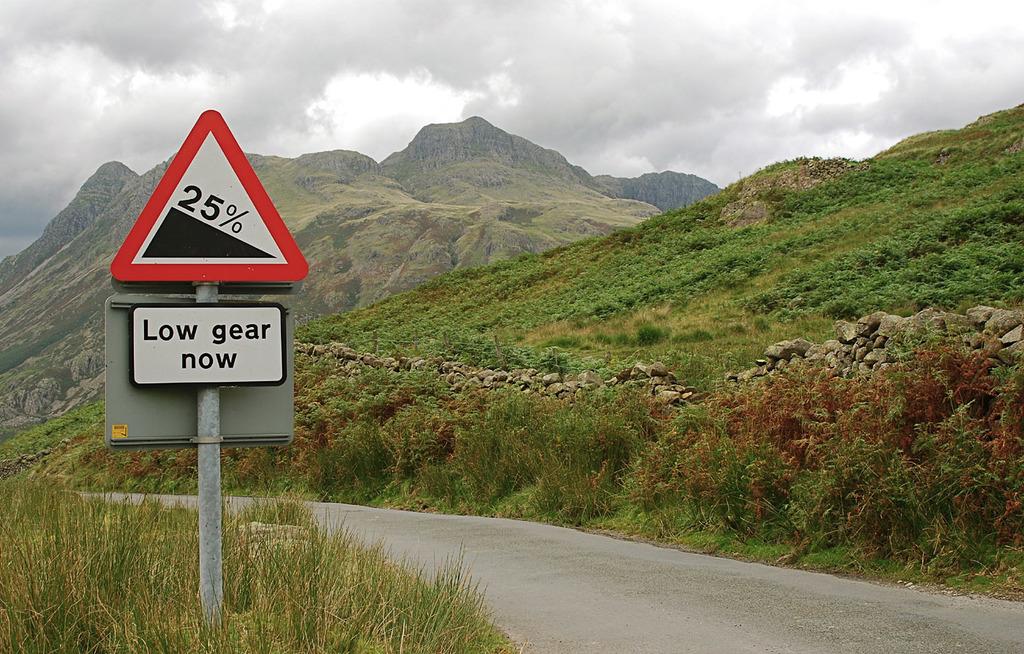What caution should you take?
Keep it short and to the point. Low gear now. Whats the sign warning?
Provide a short and direct response. Low gear now. 